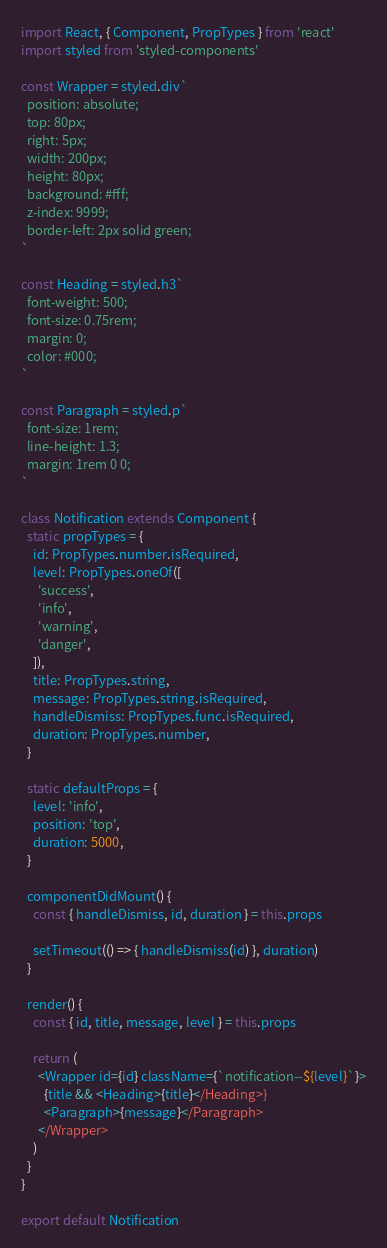<code> <loc_0><loc_0><loc_500><loc_500><_JavaScript_>import React, { Component, PropTypes } from 'react'
import styled from 'styled-components'

const Wrapper = styled.div`
  position: absolute;
  top: 80px;
  right: 5px;
  width: 200px;
  height: 80px;
  background: #fff;
  z-index: 9999;
  border-left: 2px solid green;
`

const Heading = styled.h3`
  font-weight: 500;
  font-size: 0.75rem;
  margin: 0;
  color: #000;
`

const Paragraph = styled.p`
  font-size: 1rem;
  line-height: 1.3;
  margin: 1rem 0 0;
`

class Notification extends Component {
  static propTypes = {
    id: PropTypes.number.isRequired,
    level: PropTypes.oneOf([
      'success',
      'info',
      'warning',
      'danger',
    ]),
    title: PropTypes.string,
    message: PropTypes.string.isRequired,
    handleDismiss: PropTypes.func.isRequired,
    duration: PropTypes.number,
  }

  static defaultProps = {
    level: 'info',
    position: 'top',
    duration: 5000,
  }

  componentDidMount() {
    const { handleDismiss, id, duration } = this.props

    setTimeout(() => { handleDismiss(id) }, duration)
  }

  render() {
    const { id, title, message, level } = this.props

    return (
      <Wrapper id={id} className={`notification--${level}`}>
        {title && <Heading>{title}</Heading>}
        <Paragraph>{message}</Paragraph>
      </Wrapper>
    )
  }
}

export default Notification
</code> 